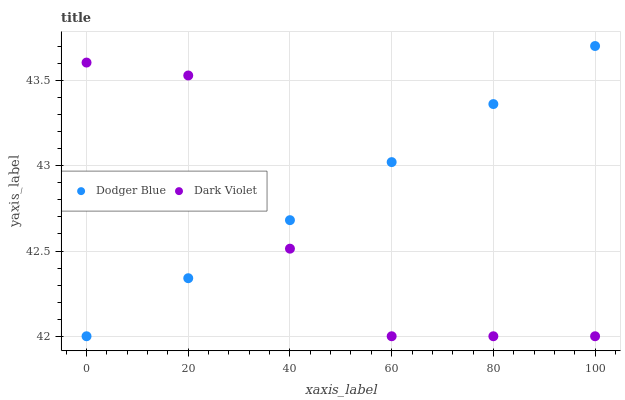Does Dark Violet have the minimum area under the curve?
Answer yes or no. Yes. Does Dodger Blue have the maximum area under the curve?
Answer yes or no. Yes. Does Dark Violet have the maximum area under the curve?
Answer yes or no. No. Is Dodger Blue the smoothest?
Answer yes or no. Yes. Is Dark Violet the roughest?
Answer yes or no. Yes. Is Dark Violet the smoothest?
Answer yes or no. No. Does Dodger Blue have the lowest value?
Answer yes or no. Yes. Does Dodger Blue have the highest value?
Answer yes or no. Yes. Does Dark Violet have the highest value?
Answer yes or no. No. Does Dark Violet intersect Dodger Blue?
Answer yes or no. Yes. Is Dark Violet less than Dodger Blue?
Answer yes or no. No. Is Dark Violet greater than Dodger Blue?
Answer yes or no. No. 